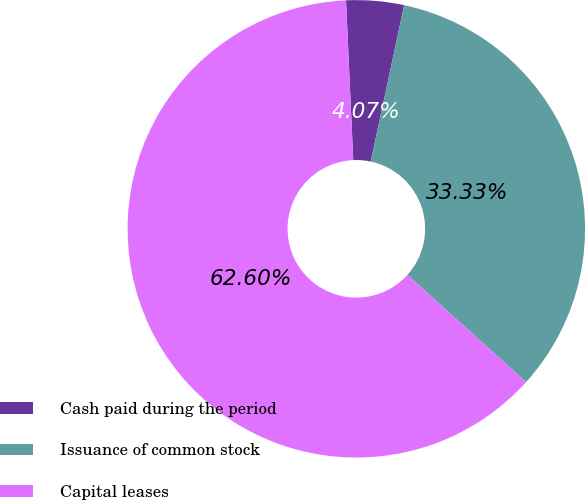Convert chart. <chart><loc_0><loc_0><loc_500><loc_500><pie_chart><fcel>Cash paid during the period<fcel>Issuance of common stock<fcel>Capital leases<nl><fcel>4.07%<fcel>33.33%<fcel>62.59%<nl></chart> 